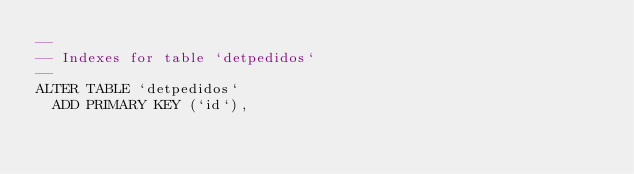<code> <loc_0><loc_0><loc_500><loc_500><_SQL_>--
-- Indexes for table `detpedidos`
--
ALTER TABLE `detpedidos`
  ADD PRIMARY KEY (`id`),</code> 